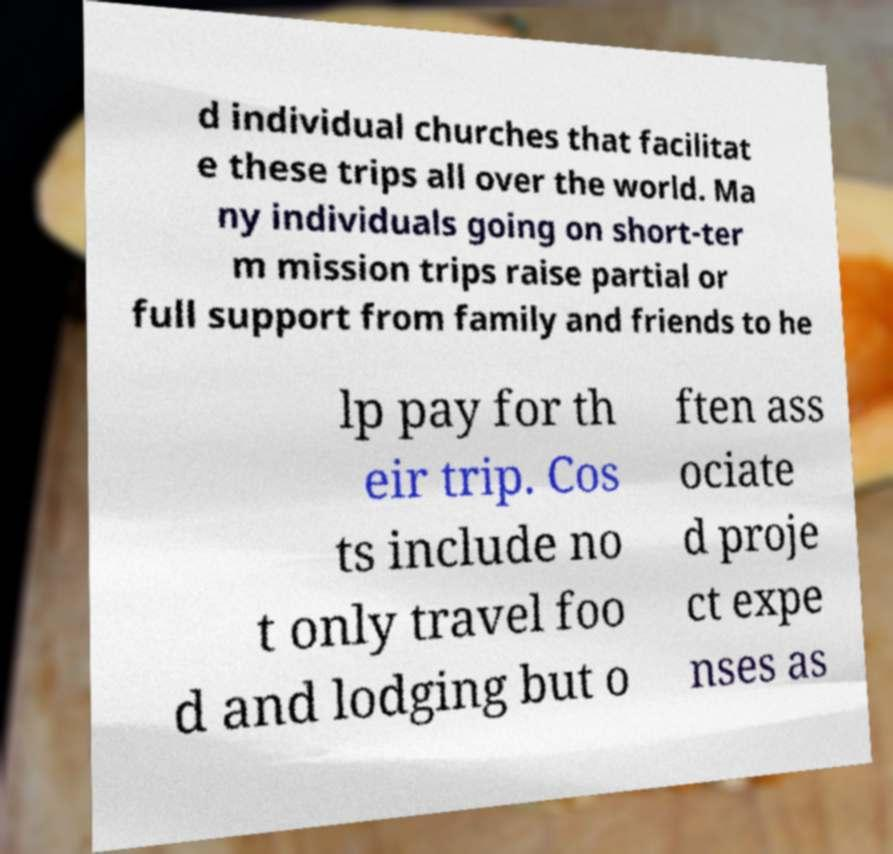Please identify and transcribe the text found in this image. d individual churches that facilitat e these trips all over the world. Ma ny individuals going on short-ter m mission trips raise partial or full support from family and friends to he lp pay for th eir trip. Cos ts include no t only travel foo d and lodging but o ften ass ociate d proje ct expe nses as 